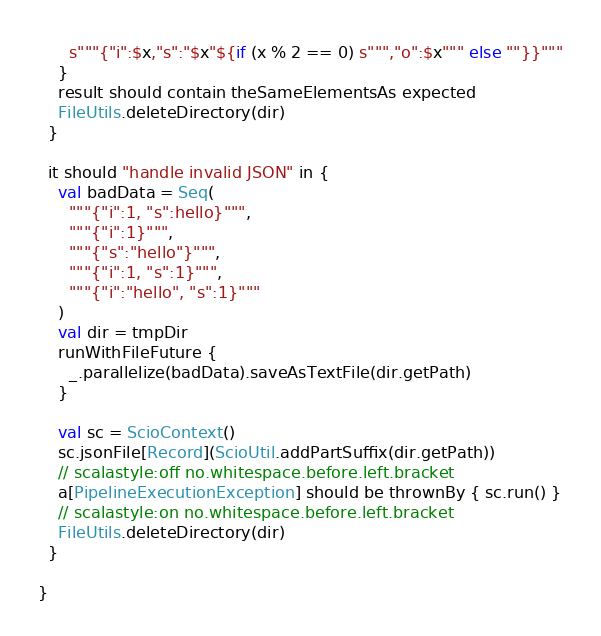<code> <loc_0><loc_0><loc_500><loc_500><_Scala_>      s"""{"i":$x,"s":"$x"${if (x % 2 == 0) s""","o":$x""" else ""}}"""
    }
    result should contain theSameElementsAs expected
    FileUtils.deleteDirectory(dir)
  }

  it should "handle invalid JSON" in {
    val badData = Seq(
      """{"i":1, "s":hello}""",
      """{"i":1}""",
      """{"s":"hello"}""",
      """{"i":1, "s":1}""",
      """{"i":"hello", "s":1}"""
    )
    val dir = tmpDir
    runWithFileFuture {
      _.parallelize(badData).saveAsTextFile(dir.getPath)
    }

    val sc = ScioContext()
    sc.jsonFile[Record](ScioUtil.addPartSuffix(dir.getPath))
    // scalastyle:off no.whitespace.before.left.bracket
    a[PipelineExecutionException] should be thrownBy { sc.run() }
    // scalastyle:on no.whitespace.before.left.bracket
    FileUtils.deleteDirectory(dir)
  }

}
</code> 